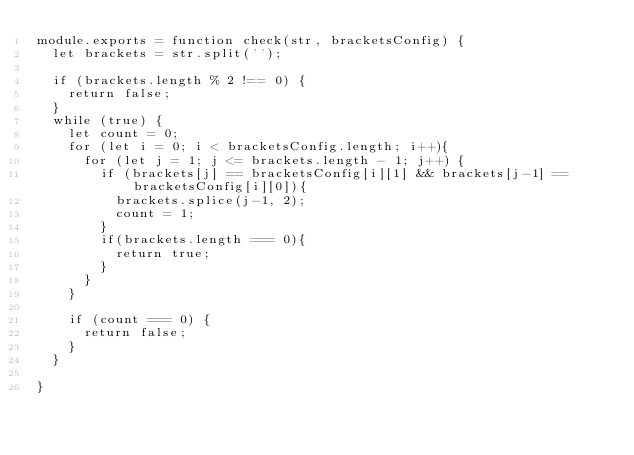<code> <loc_0><loc_0><loc_500><loc_500><_JavaScript_>module.exports = function check(str, bracketsConfig) {
  let brackets = str.split('');

  if (brackets.length % 2 !== 0) {
    return false;
  }
  while (true) {
    let count = 0;
    for (let i = 0; i < bracketsConfig.length; i++){
      for (let j = 1; j <= brackets.length - 1; j++) {
        if (brackets[j] == bracketsConfig[i][1] && brackets[j-1] == bracketsConfig[i][0]){
          brackets.splice(j-1, 2);
          count = 1;
        }
        if(brackets.length === 0){
          return true;
        }
      }
    }

    if (count === 0) {
      return false;
    }
  }

}
</code> 